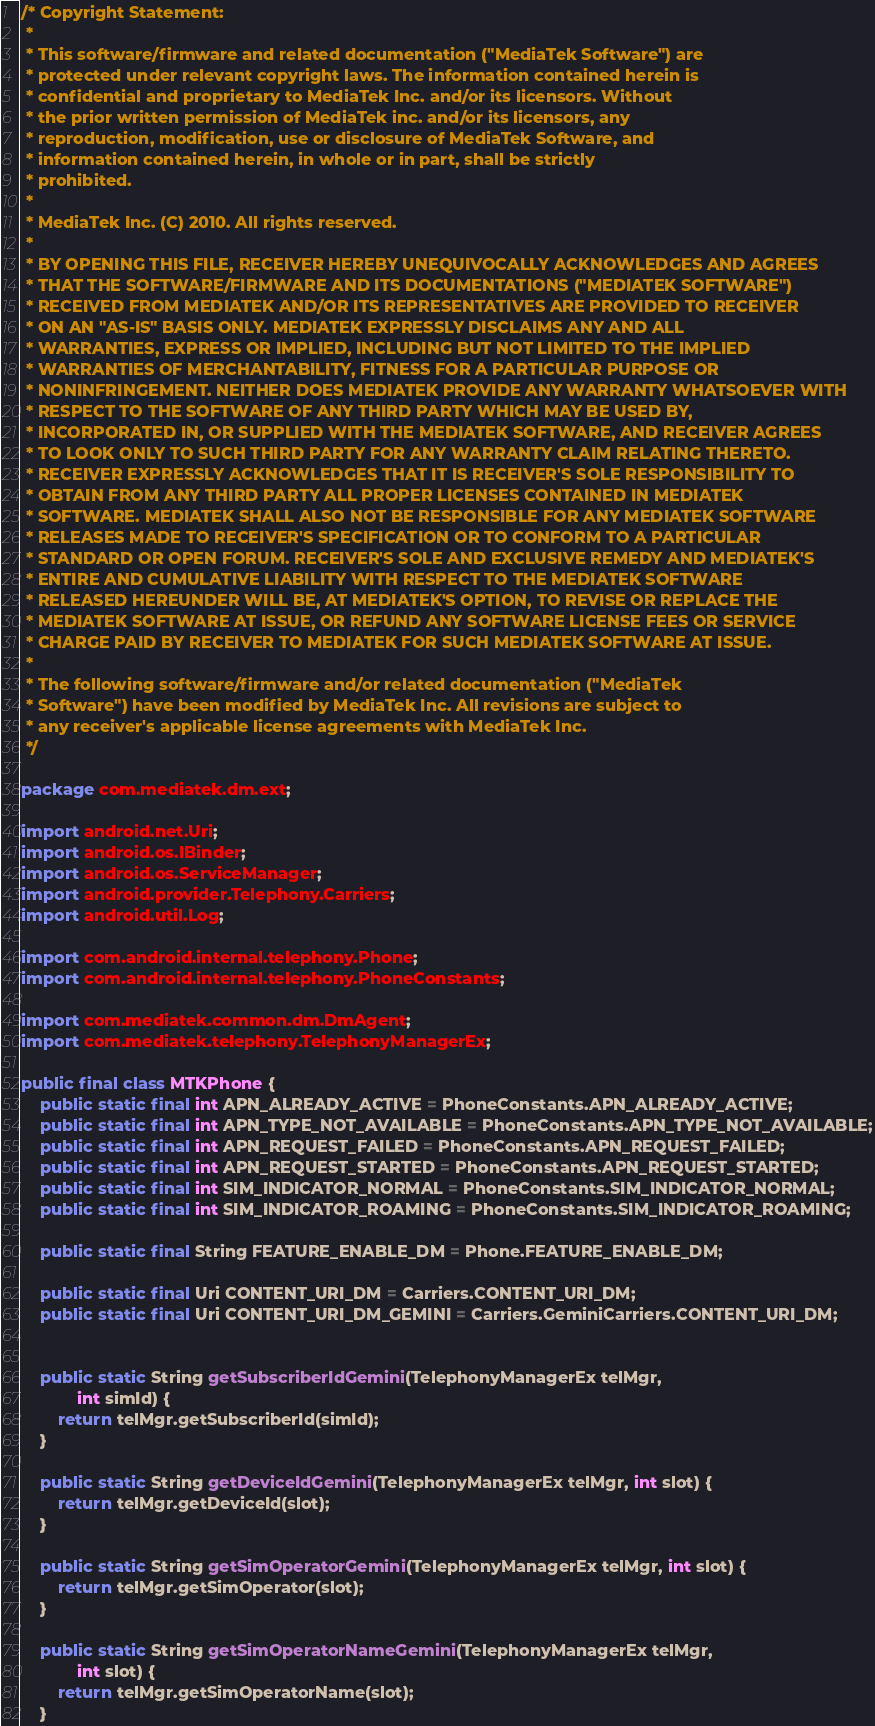<code> <loc_0><loc_0><loc_500><loc_500><_Java_>/* Copyright Statement:
 *
 * This software/firmware and related documentation ("MediaTek Software") are
 * protected under relevant copyright laws. The information contained herein is
 * confidential and proprietary to MediaTek Inc. and/or its licensors. Without
 * the prior written permission of MediaTek inc. and/or its licensors, any
 * reproduction, modification, use or disclosure of MediaTek Software, and
 * information contained herein, in whole or in part, shall be strictly
 * prohibited.
 * 
 * MediaTek Inc. (C) 2010. All rights reserved.
 * 
 * BY OPENING THIS FILE, RECEIVER HEREBY UNEQUIVOCALLY ACKNOWLEDGES AND AGREES
 * THAT THE SOFTWARE/FIRMWARE AND ITS DOCUMENTATIONS ("MEDIATEK SOFTWARE")
 * RECEIVED FROM MEDIATEK AND/OR ITS REPRESENTATIVES ARE PROVIDED TO RECEIVER
 * ON AN "AS-IS" BASIS ONLY. MEDIATEK EXPRESSLY DISCLAIMS ANY AND ALL
 * WARRANTIES, EXPRESS OR IMPLIED, INCLUDING BUT NOT LIMITED TO THE IMPLIED
 * WARRANTIES OF MERCHANTABILITY, FITNESS FOR A PARTICULAR PURPOSE OR
 * NONINFRINGEMENT. NEITHER DOES MEDIATEK PROVIDE ANY WARRANTY WHATSOEVER WITH
 * RESPECT TO THE SOFTWARE OF ANY THIRD PARTY WHICH MAY BE USED BY,
 * INCORPORATED IN, OR SUPPLIED WITH THE MEDIATEK SOFTWARE, AND RECEIVER AGREES
 * TO LOOK ONLY TO SUCH THIRD PARTY FOR ANY WARRANTY CLAIM RELATING THERETO.
 * RECEIVER EXPRESSLY ACKNOWLEDGES THAT IT IS RECEIVER'S SOLE RESPONSIBILITY TO
 * OBTAIN FROM ANY THIRD PARTY ALL PROPER LICENSES CONTAINED IN MEDIATEK
 * SOFTWARE. MEDIATEK SHALL ALSO NOT BE RESPONSIBLE FOR ANY MEDIATEK SOFTWARE
 * RELEASES MADE TO RECEIVER'S SPECIFICATION OR TO CONFORM TO A PARTICULAR
 * STANDARD OR OPEN FORUM. RECEIVER'S SOLE AND EXCLUSIVE REMEDY AND MEDIATEK'S
 * ENTIRE AND CUMULATIVE LIABILITY WITH RESPECT TO THE MEDIATEK SOFTWARE
 * RELEASED HEREUNDER WILL BE, AT MEDIATEK'S OPTION, TO REVISE OR REPLACE THE
 * MEDIATEK SOFTWARE AT ISSUE, OR REFUND ANY SOFTWARE LICENSE FEES OR SERVICE
 * CHARGE PAID BY RECEIVER TO MEDIATEK FOR SUCH MEDIATEK SOFTWARE AT ISSUE.
 *
 * The following software/firmware and/or related documentation ("MediaTek
 * Software") have been modified by MediaTek Inc. All revisions are subject to
 * any receiver's applicable license agreements with MediaTek Inc.
 */

package com.mediatek.dm.ext;

import android.net.Uri;
import android.os.IBinder;
import android.os.ServiceManager;
import android.provider.Telephony.Carriers;
import android.util.Log;

import com.android.internal.telephony.Phone;
import com.android.internal.telephony.PhoneConstants;

import com.mediatek.common.dm.DmAgent;
import com.mediatek.telephony.TelephonyManagerEx;

public final class MTKPhone {
    public static final int APN_ALREADY_ACTIVE = PhoneConstants.APN_ALREADY_ACTIVE;
    public static final int APN_TYPE_NOT_AVAILABLE = PhoneConstants.APN_TYPE_NOT_AVAILABLE;
    public static final int APN_REQUEST_FAILED = PhoneConstants.APN_REQUEST_FAILED;
    public static final int APN_REQUEST_STARTED = PhoneConstants.APN_REQUEST_STARTED;
    public static final int SIM_INDICATOR_NORMAL = PhoneConstants.SIM_INDICATOR_NORMAL;
    public static final int SIM_INDICATOR_ROAMING = PhoneConstants.SIM_INDICATOR_ROAMING;

    public static final String FEATURE_ENABLE_DM = Phone.FEATURE_ENABLE_DM;

    public static final Uri CONTENT_URI_DM = Carriers.CONTENT_URI_DM;
    public static final Uri CONTENT_URI_DM_GEMINI = Carriers.GeminiCarriers.CONTENT_URI_DM;
    

    public static String getSubscriberIdGemini(TelephonyManagerEx telMgr,
            int simId) {
        return telMgr.getSubscriberId(simId);
    }

    public static String getDeviceIdGemini(TelephonyManagerEx telMgr, int slot) {
        return telMgr.getDeviceId(slot);
    }

    public static String getSimOperatorGemini(TelephonyManagerEx telMgr, int slot) {
        return telMgr.getSimOperator(slot);
    }

    public static String getSimOperatorNameGemini(TelephonyManagerEx telMgr,
            int slot) {
        return telMgr.getSimOperatorName(slot);
    }
</code> 